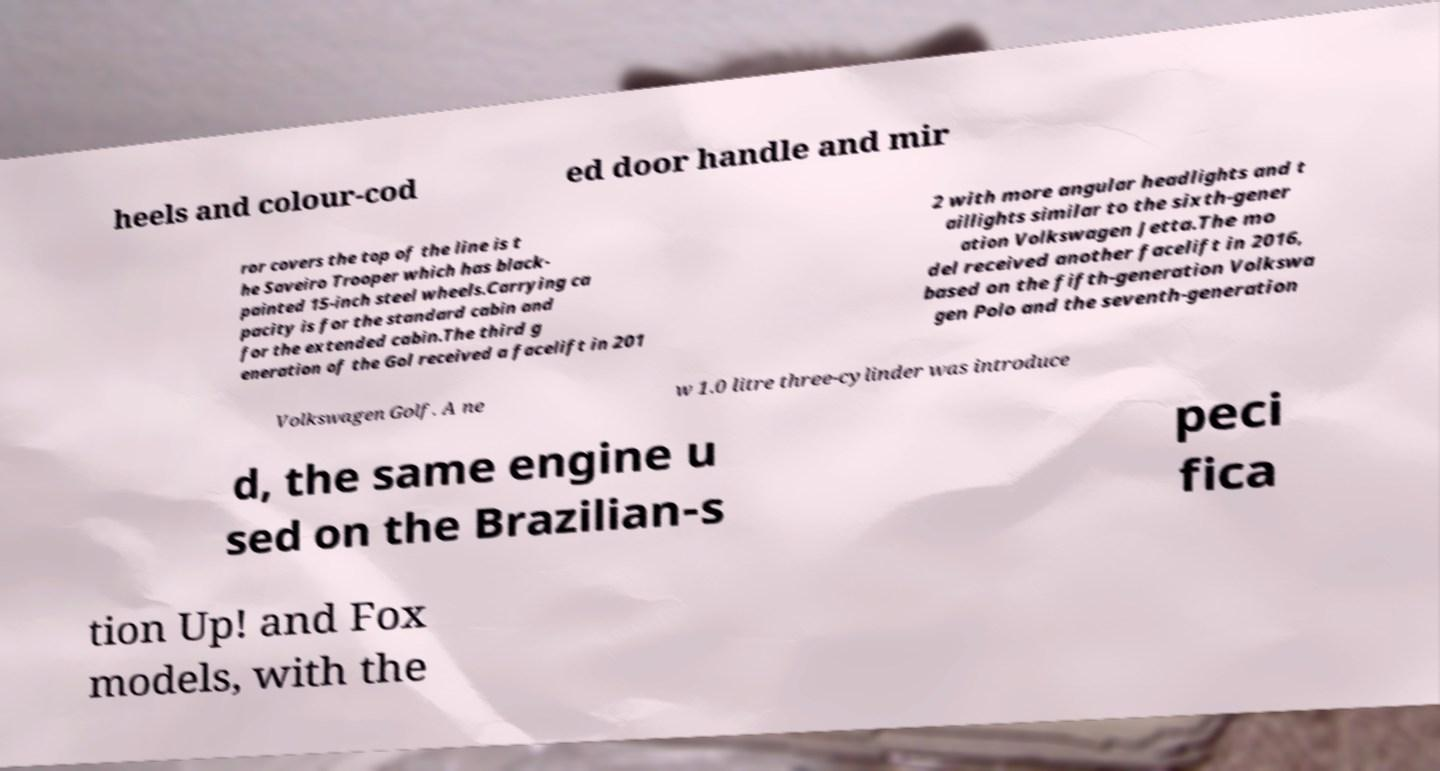Could you assist in decoding the text presented in this image and type it out clearly? heels and colour-cod ed door handle and mir ror covers the top of the line is t he Saveiro Trooper which has black- painted 15-inch steel wheels.Carrying ca pacity is for the standard cabin and for the extended cabin.The third g eneration of the Gol received a facelift in 201 2 with more angular headlights and t aillights similar to the sixth-gener ation Volkswagen Jetta.The mo del received another facelift in 2016, based on the fifth-generation Volkswa gen Polo and the seventh-generation Volkswagen Golf. A ne w 1.0 litre three-cylinder was introduce d, the same engine u sed on the Brazilian-s peci fica tion Up! and Fox models, with the 